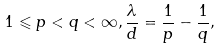Convert formula to latex. <formula><loc_0><loc_0><loc_500><loc_500>1 \leqslant p < q < \infty , \frac { \lambda } { d } = \frac { 1 } { p } - \frac { 1 } { q } ,</formula> 